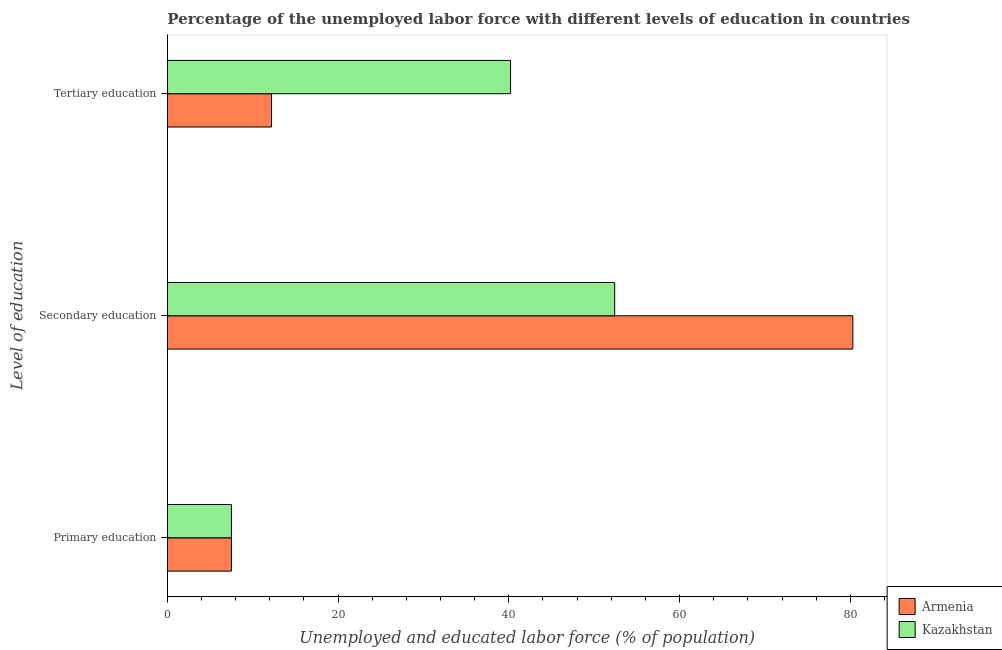How many different coloured bars are there?
Ensure brevity in your answer.  2. Are the number of bars per tick equal to the number of legend labels?
Make the answer very short. Yes. Are the number of bars on each tick of the Y-axis equal?
Give a very brief answer. Yes. How many bars are there on the 3rd tick from the top?
Your answer should be compact. 2. What is the percentage of labor force who received tertiary education in Armenia?
Provide a short and direct response. 12.2. Across all countries, what is the maximum percentage of labor force who received tertiary education?
Make the answer very short. 40.2. Across all countries, what is the minimum percentage of labor force who received secondary education?
Your answer should be very brief. 52.4. In which country was the percentage of labor force who received primary education maximum?
Your answer should be compact. Armenia. In which country was the percentage of labor force who received secondary education minimum?
Make the answer very short. Kazakhstan. What is the total percentage of labor force who received primary education in the graph?
Provide a succinct answer. 15. What is the difference between the percentage of labor force who received tertiary education in Kazakhstan and that in Armenia?
Your response must be concise. 28. What is the difference between the percentage of labor force who received secondary education in Armenia and the percentage of labor force who received primary education in Kazakhstan?
Offer a terse response. 72.8. What is the difference between the percentage of labor force who received tertiary education and percentage of labor force who received primary education in Kazakhstan?
Make the answer very short. 32.7. What is the ratio of the percentage of labor force who received primary education in Kazakhstan to that in Armenia?
Make the answer very short. 1. Is the difference between the percentage of labor force who received primary education in Kazakhstan and Armenia greater than the difference between the percentage of labor force who received secondary education in Kazakhstan and Armenia?
Give a very brief answer. Yes. What is the difference between the highest and the second highest percentage of labor force who received primary education?
Give a very brief answer. 0. Is the sum of the percentage of labor force who received primary education in Armenia and Kazakhstan greater than the maximum percentage of labor force who received secondary education across all countries?
Provide a short and direct response. No. What does the 2nd bar from the top in Secondary education represents?
Your answer should be compact. Armenia. What does the 1st bar from the bottom in Primary education represents?
Your answer should be compact. Armenia. What is the difference between two consecutive major ticks on the X-axis?
Provide a succinct answer. 20. Does the graph contain any zero values?
Your response must be concise. No. How many legend labels are there?
Ensure brevity in your answer.  2. How are the legend labels stacked?
Keep it short and to the point. Vertical. What is the title of the graph?
Keep it short and to the point. Percentage of the unemployed labor force with different levels of education in countries. Does "Caribbean small states" appear as one of the legend labels in the graph?
Make the answer very short. No. What is the label or title of the X-axis?
Your response must be concise. Unemployed and educated labor force (% of population). What is the label or title of the Y-axis?
Your answer should be compact. Level of education. What is the Unemployed and educated labor force (% of population) of Armenia in Primary education?
Ensure brevity in your answer.  7.5. What is the Unemployed and educated labor force (% of population) of Armenia in Secondary education?
Offer a very short reply. 80.3. What is the Unemployed and educated labor force (% of population) in Kazakhstan in Secondary education?
Ensure brevity in your answer.  52.4. What is the Unemployed and educated labor force (% of population) in Armenia in Tertiary education?
Provide a succinct answer. 12.2. What is the Unemployed and educated labor force (% of population) in Kazakhstan in Tertiary education?
Provide a short and direct response. 40.2. Across all Level of education, what is the maximum Unemployed and educated labor force (% of population) in Armenia?
Offer a very short reply. 80.3. Across all Level of education, what is the maximum Unemployed and educated labor force (% of population) of Kazakhstan?
Keep it short and to the point. 52.4. Across all Level of education, what is the minimum Unemployed and educated labor force (% of population) of Kazakhstan?
Give a very brief answer. 7.5. What is the total Unemployed and educated labor force (% of population) of Armenia in the graph?
Give a very brief answer. 100. What is the total Unemployed and educated labor force (% of population) of Kazakhstan in the graph?
Make the answer very short. 100.1. What is the difference between the Unemployed and educated labor force (% of population) of Armenia in Primary education and that in Secondary education?
Keep it short and to the point. -72.8. What is the difference between the Unemployed and educated labor force (% of population) in Kazakhstan in Primary education and that in Secondary education?
Offer a terse response. -44.9. What is the difference between the Unemployed and educated labor force (% of population) of Kazakhstan in Primary education and that in Tertiary education?
Provide a succinct answer. -32.7. What is the difference between the Unemployed and educated labor force (% of population) of Armenia in Secondary education and that in Tertiary education?
Offer a terse response. 68.1. What is the difference between the Unemployed and educated labor force (% of population) in Armenia in Primary education and the Unemployed and educated labor force (% of population) in Kazakhstan in Secondary education?
Keep it short and to the point. -44.9. What is the difference between the Unemployed and educated labor force (% of population) in Armenia in Primary education and the Unemployed and educated labor force (% of population) in Kazakhstan in Tertiary education?
Give a very brief answer. -32.7. What is the difference between the Unemployed and educated labor force (% of population) of Armenia in Secondary education and the Unemployed and educated labor force (% of population) of Kazakhstan in Tertiary education?
Provide a short and direct response. 40.1. What is the average Unemployed and educated labor force (% of population) of Armenia per Level of education?
Provide a short and direct response. 33.33. What is the average Unemployed and educated labor force (% of population) in Kazakhstan per Level of education?
Provide a short and direct response. 33.37. What is the difference between the Unemployed and educated labor force (% of population) in Armenia and Unemployed and educated labor force (% of population) in Kazakhstan in Primary education?
Your answer should be very brief. 0. What is the difference between the Unemployed and educated labor force (% of population) of Armenia and Unemployed and educated labor force (% of population) of Kazakhstan in Secondary education?
Your answer should be compact. 27.9. What is the ratio of the Unemployed and educated labor force (% of population) in Armenia in Primary education to that in Secondary education?
Make the answer very short. 0.09. What is the ratio of the Unemployed and educated labor force (% of population) of Kazakhstan in Primary education to that in Secondary education?
Your answer should be compact. 0.14. What is the ratio of the Unemployed and educated labor force (% of population) in Armenia in Primary education to that in Tertiary education?
Provide a succinct answer. 0.61. What is the ratio of the Unemployed and educated labor force (% of population) of Kazakhstan in Primary education to that in Tertiary education?
Give a very brief answer. 0.19. What is the ratio of the Unemployed and educated labor force (% of population) of Armenia in Secondary education to that in Tertiary education?
Make the answer very short. 6.58. What is the ratio of the Unemployed and educated labor force (% of population) in Kazakhstan in Secondary education to that in Tertiary education?
Your response must be concise. 1.3. What is the difference between the highest and the second highest Unemployed and educated labor force (% of population) in Armenia?
Keep it short and to the point. 68.1. What is the difference between the highest and the lowest Unemployed and educated labor force (% of population) of Armenia?
Ensure brevity in your answer.  72.8. What is the difference between the highest and the lowest Unemployed and educated labor force (% of population) of Kazakhstan?
Provide a succinct answer. 44.9. 